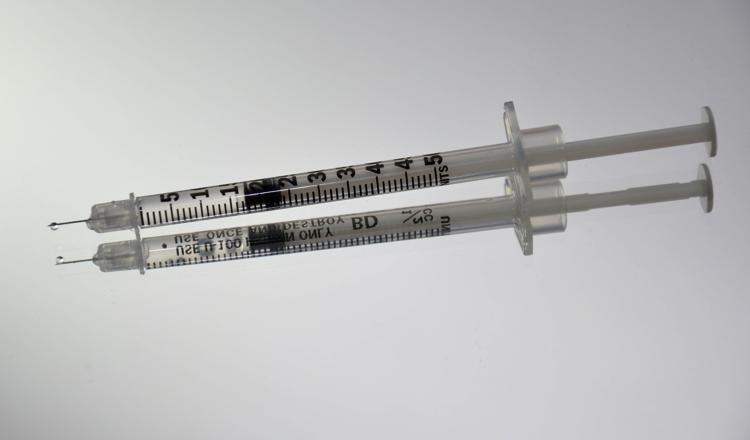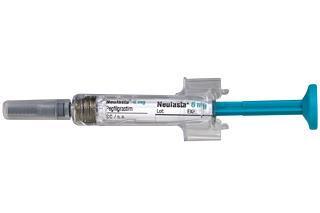The first image is the image on the left, the second image is the image on the right. For the images displayed, is the sentence "The right image includes more syringe-type tubes than the left image." factually correct? Answer yes or no. No. The first image is the image on the left, the second image is the image on the right. Examine the images to the left and right. Is the description "There are more syringes in the image on the right." accurate? Answer yes or no. No. 